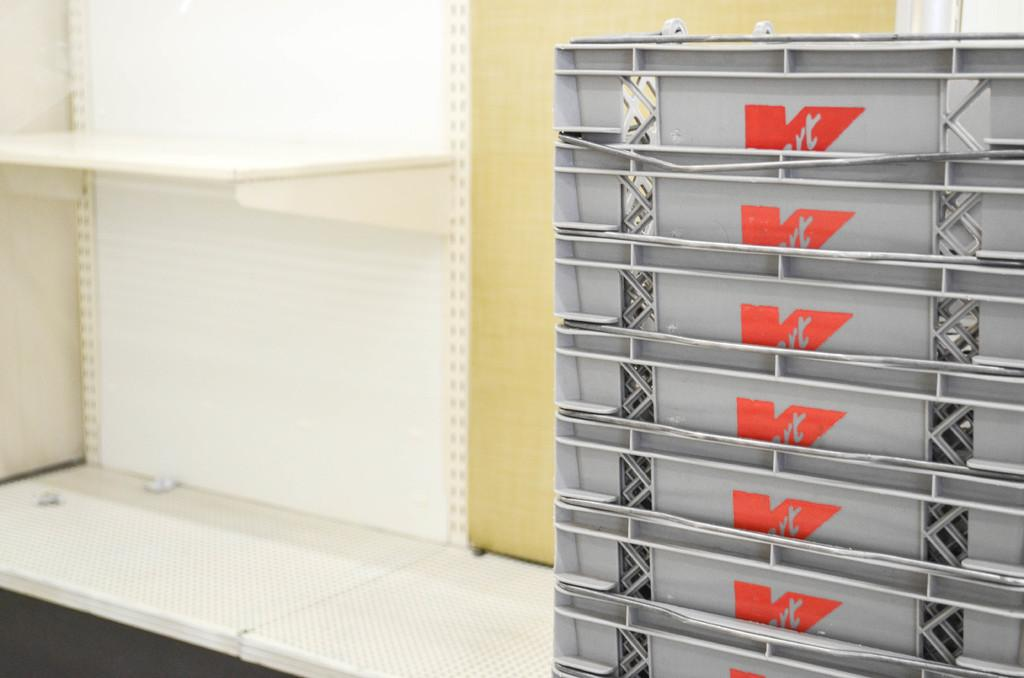Provide a one-sentence caption for the provided image. A stack of K-Mart baskets sit in the back room of a store. 